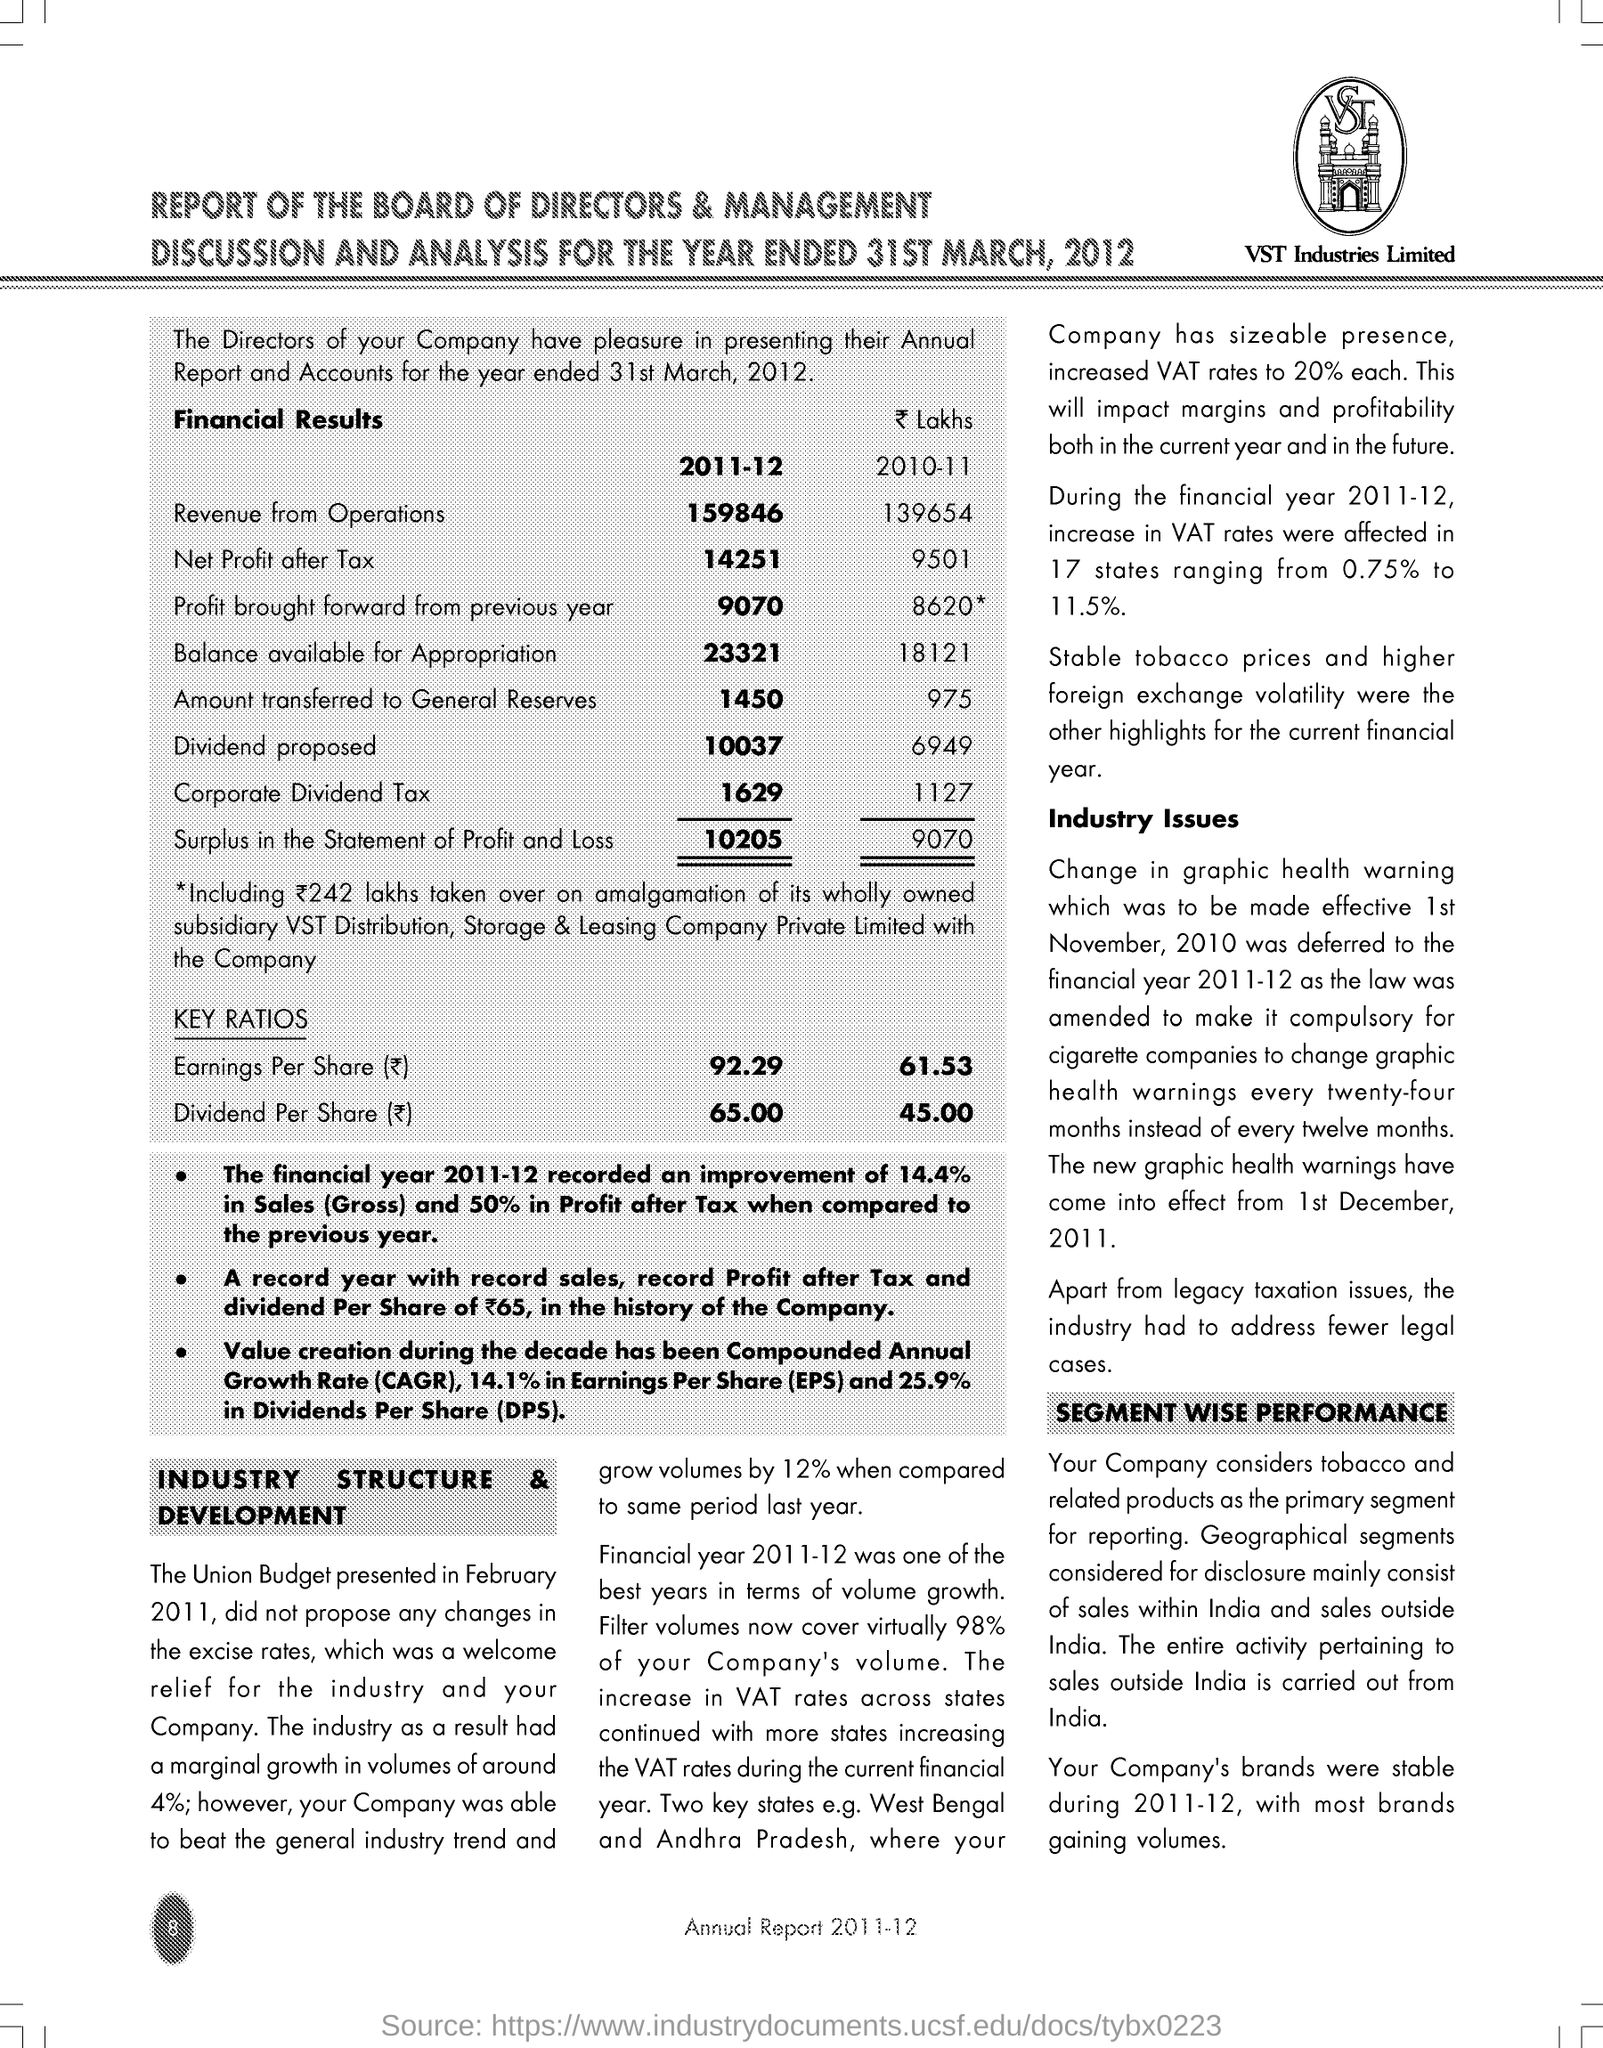Highlight a few significant elements in this photo. Compounded Annual Growth Rate, commonly referred to as CAGR, is a measure of the rate of increase in the value of a financial asset or investment over a specific period of time. It takes into account both the principal and any accumulated interest or dividends. CAGR is a useful tool for investors and analysts to evaluate the long-term performance of an investment and make informed decisions about their financial future. EPS stands for Earnings Per Share, a measure of a company's profitability and financial performance, calculated by dividing its net income by the number of outstanding shares of its common stock. In the 2011-12 financial year, a total of 1,450 was transferred to the general reserves. The earnings per share in rupees for the year 2010-11 was 61.53. 